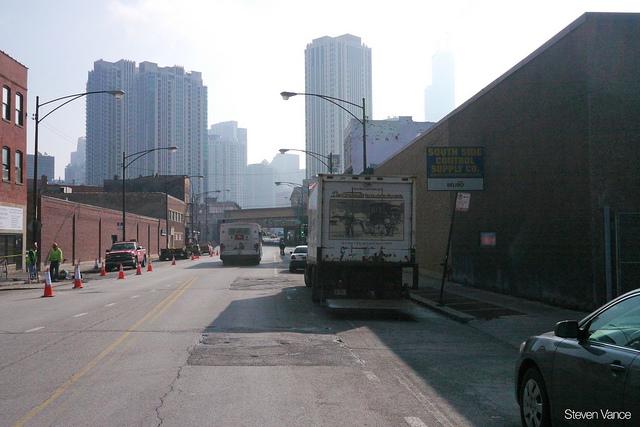Is it foggy out?
Short answer required. Yes. What color are the street lines?
Concise answer only. Yellow. What kind of buildings are at the far end of the street?
Keep it brief. Skyscrapers. 